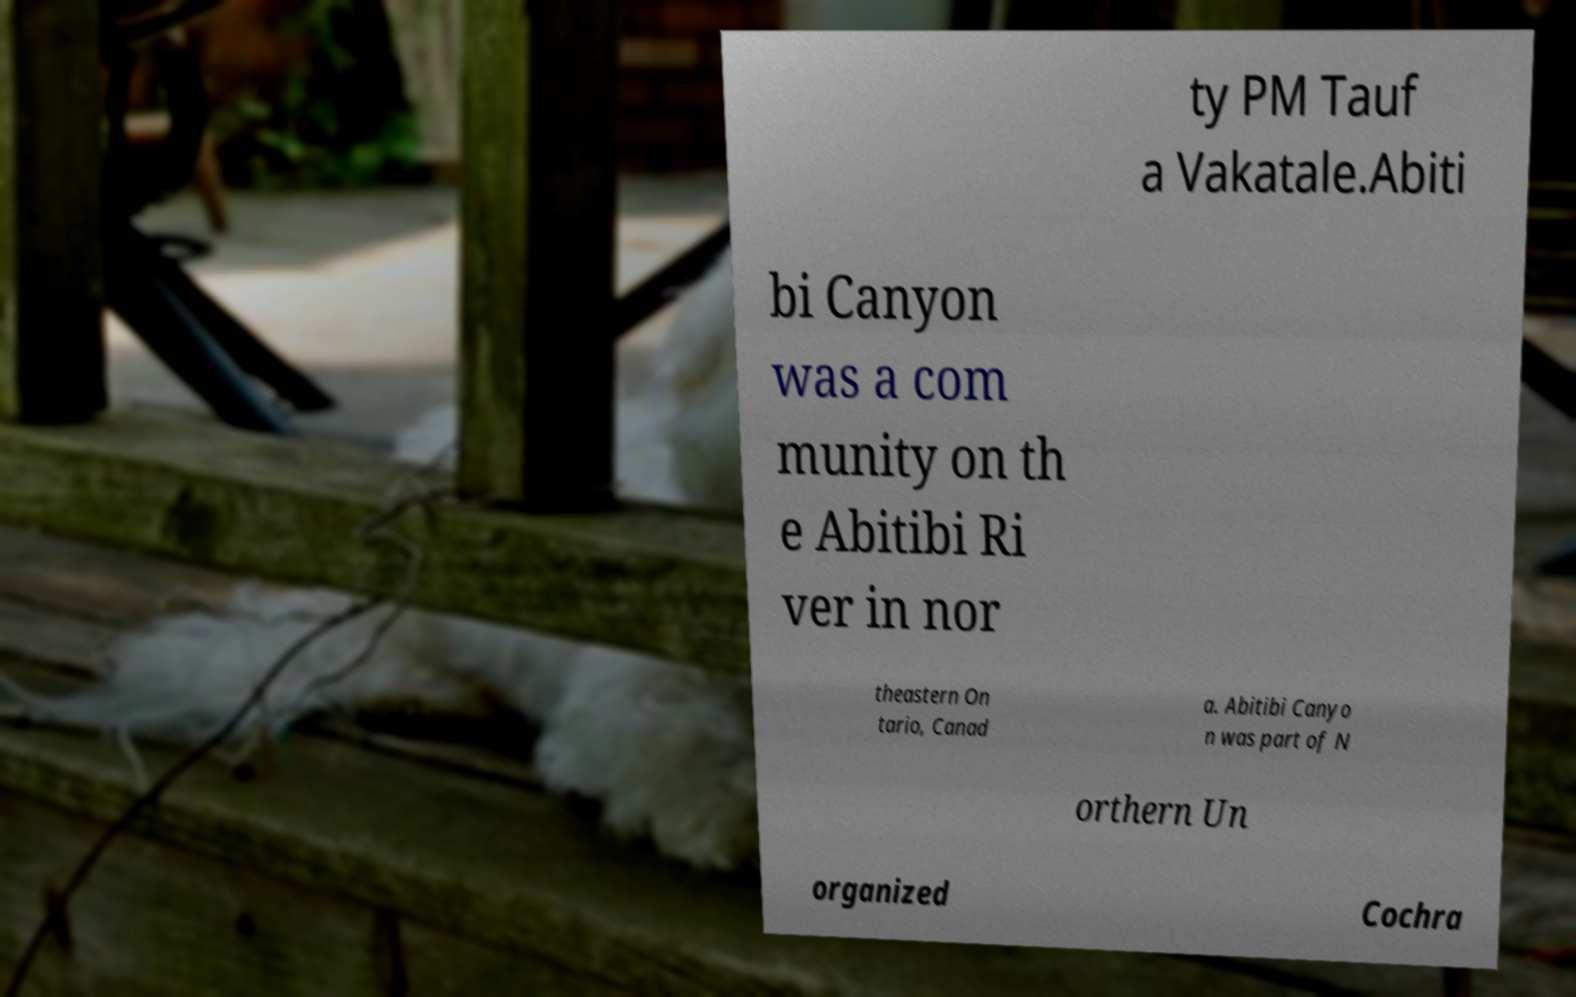There's text embedded in this image that I need extracted. Can you transcribe it verbatim? ty PM Tauf a Vakatale.Abiti bi Canyon was a com munity on th e Abitibi Ri ver in nor theastern On tario, Canad a. Abitibi Canyo n was part of N orthern Un organized Cochra 